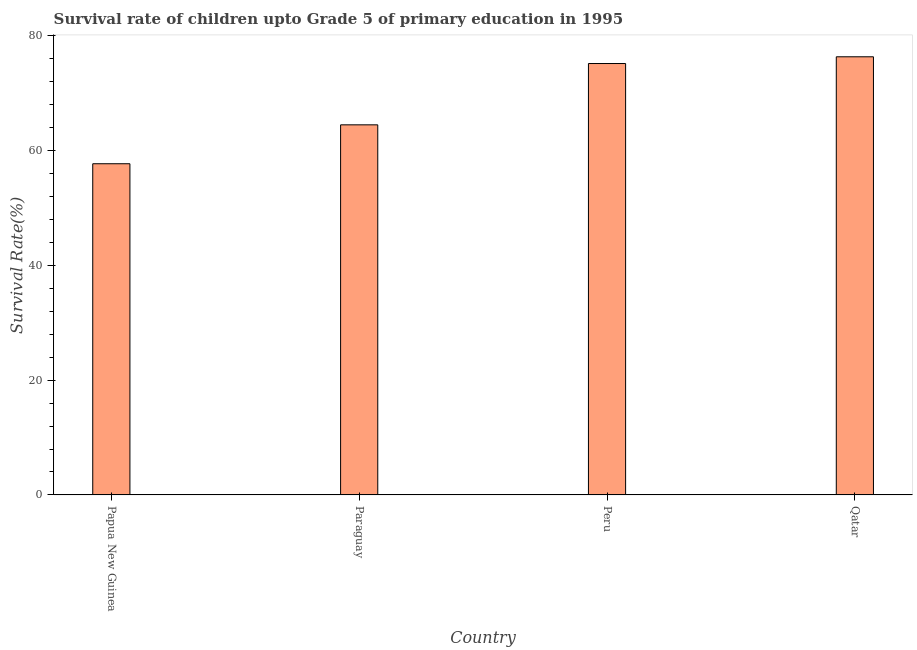Does the graph contain any zero values?
Your answer should be very brief. No. Does the graph contain grids?
Offer a very short reply. No. What is the title of the graph?
Provide a succinct answer. Survival rate of children upto Grade 5 of primary education in 1995 . What is the label or title of the Y-axis?
Ensure brevity in your answer.  Survival Rate(%). What is the survival rate in Qatar?
Give a very brief answer. 76.32. Across all countries, what is the maximum survival rate?
Your answer should be very brief. 76.32. Across all countries, what is the minimum survival rate?
Your answer should be very brief. 57.69. In which country was the survival rate maximum?
Offer a very short reply. Qatar. In which country was the survival rate minimum?
Offer a terse response. Papua New Guinea. What is the sum of the survival rate?
Provide a short and direct response. 273.63. What is the difference between the survival rate in Paraguay and Qatar?
Provide a succinct answer. -11.85. What is the average survival rate per country?
Keep it short and to the point. 68.41. What is the median survival rate?
Provide a succinct answer. 69.81. What is the ratio of the survival rate in Paraguay to that in Qatar?
Provide a short and direct response. 0.84. Is the difference between the survival rate in Paraguay and Peru greater than the difference between any two countries?
Keep it short and to the point. No. What is the difference between the highest and the second highest survival rate?
Make the answer very short. 1.17. Is the sum of the survival rate in Paraguay and Qatar greater than the maximum survival rate across all countries?
Your response must be concise. Yes. What is the difference between the highest and the lowest survival rate?
Make the answer very short. 18.63. Are all the bars in the graph horizontal?
Provide a short and direct response. No. How many countries are there in the graph?
Ensure brevity in your answer.  4. Are the values on the major ticks of Y-axis written in scientific E-notation?
Make the answer very short. No. What is the Survival Rate(%) in Papua New Guinea?
Provide a short and direct response. 57.69. What is the Survival Rate(%) in Paraguay?
Offer a terse response. 64.47. What is the Survival Rate(%) in Peru?
Keep it short and to the point. 75.15. What is the Survival Rate(%) of Qatar?
Your answer should be compact. 76.32. What is the difference between the Survival Rate(%) in Papua New Guinea and Paraguay?
Your response must be concise. -6.78. What is the difference between the Survival Rate(%) in Papua New Guinea and Peru?
Provide a succinct answer. -17.46. What is the difference between the Survival Rate(%) in Papua New Guinea and Qatar?
Your answer should be compact. -18.63. What is the difference between the Survival Rate(%) in Paraguay and Peru?
Provide a short and direct response. -10.68. What is the difference between the Survival Rate(%) in Paraguay and Qatar?
Make the answer very short. -11.85. What is the difference between the Survival Rate(%) in Peru and Qatar?
Provide a short and direct response. -1.17. What is the ratio of the Survival Rate(%) in Papua New Guinea to that in Paraguay?
Keep it short and to the point. 0.9. What is the ratio of the Survival Rate(%) in Papua New Guinea to that in Peru?
Ensure brevity in your answer.  0.77. What is the ratio of the Survival Rate(%) in Papua New Guinea to that in Qatar?
Keep it short and to the point. 0.76. What is the ratio of the Survival Rate(%) in Paraguay to that in Peru?
Make the answer very short. 0.86. What is the ratio of the Survival Rate(%) in Paraguay to that in Qatar?
Provide a succinct answer. 0.84. 